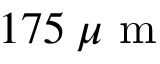<formula> <loc_0><loc_0><loc_500><loc_500>1 7 5 \, \mu m</formula> 